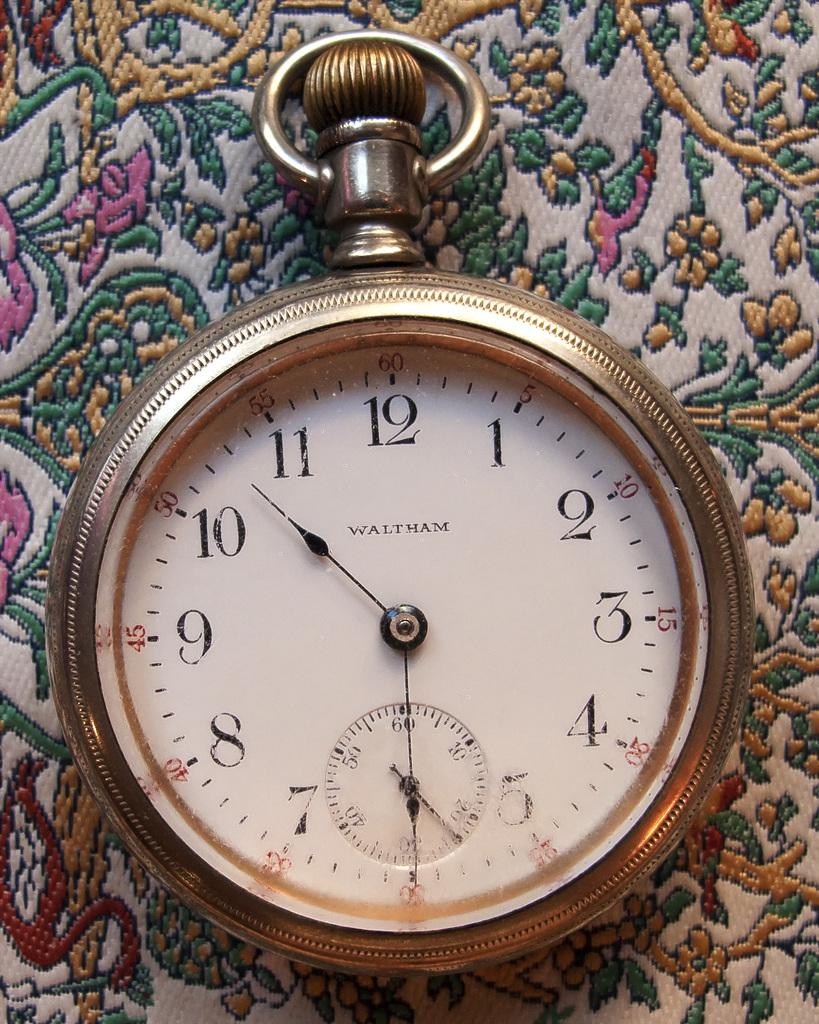<image>
Present a compact description of the photo's key features. A gold colored Waltham watch sits on a multicolored fabric. 